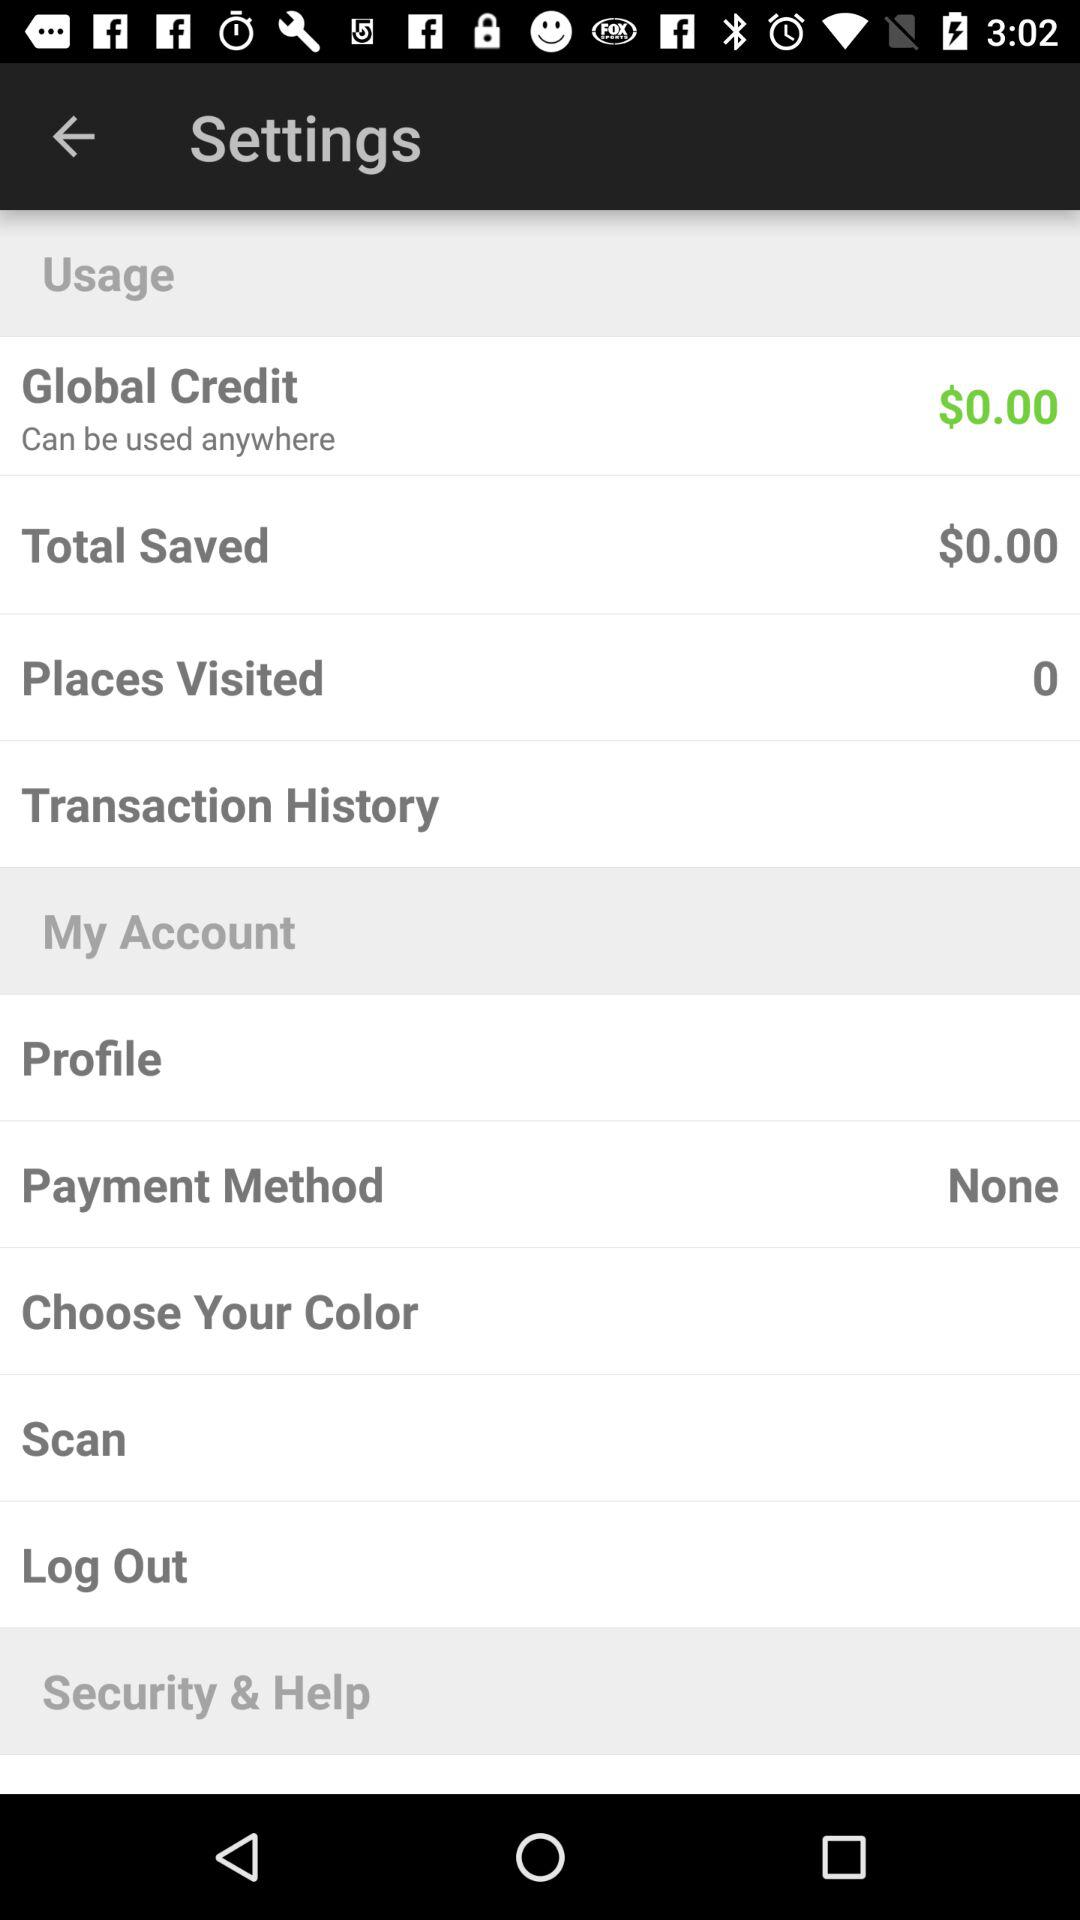How much money have I saved?
Answer the question using a single word or phrase. $0.00 